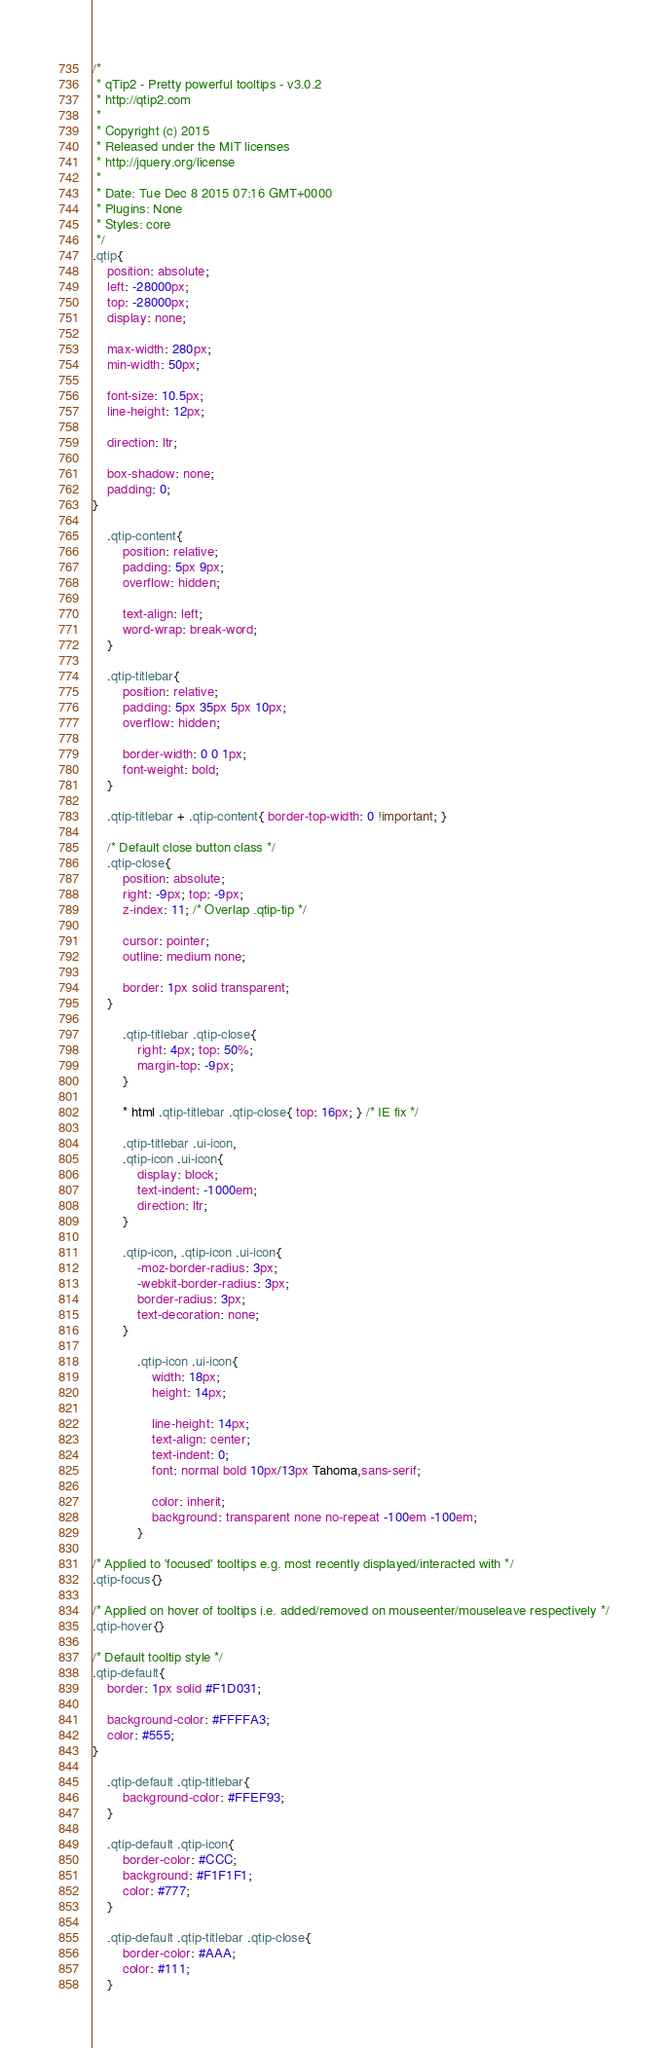Convert code to text. <code><loc_0><loc_0><loc_500><loc_500><_CSS_>/*
 * qTip2 - Pretty powerful tooltips - v3.0.2
 * http://qtip2.com
 *
 * Copyright (c) 2015 
 * Released under the MIT licenses
 * http://jquery.org/license
 *
 * Date: Tue Dec 8 2015 07:16 GMT+0000
 * Plugins: None
 * Styles: core
 */
.qtip{
	position: absolute;
	left: -28000px;
	top: -28000px;
	display: none;

	max-width: 280px;
	min-width: 50px;

	font-size: 10.5px;
	line-height: 12px;

	direction: ltr;

	box-shadow: none;
	padding: 0;
}

	.qtip-content{
		position: relative;
		padding: 5px 9px;
		overflow: hidden;

		text-align: left;
		word-wrap: break-word;
	}

	.qtip-titlebar{
		position: relative;
		padding: 5px 35px 5px 10px;
		overflow: hidden;

		border-width: 0 0 1px;
		font-weight: bold;
	}

	.qtip-titlebar + .qtip-content{ border-top-width: 0 !important; }

	/* Default close button class */
	.qtip-close{
		position: absolute;
		right: -9px; top: -9px;
		z-index: 11; /* Overlap .qtip-tip */

		cursor: pointer;
		outline: medium none;

		border: 1px solid transparent;
	}

		.qtip-titlebar .qtip-close{
			right: 4px; top: 50%;
			margin-top: -9px;
		}

		* html .qtip-titlebar .qtip-close{ top: 16px; } /* IE fix */

		.qtip-titlebar .ui-icon,
		.qtip-icon .ui-icon{
			display: block;
			text-indent: -1000em;
			direction: ltr;
		}

		.qtip-icon, .qtip-icon .ui-icon{
			-moz-border-radius: 3px;
			-webkit-border-radius: 3px;
			border-radius: 3px;
			text-decoration: none;
		}

			.qtip-icon .ui-icon{
				width: 18px;
				height: 14px;

				line-height: 14px;
				text-align: center;
				text-indent: 0;
				font: normal bold 10px/13px Tahoma,sans-serif;

				color: inherit;
				background: transparent none no-repeat -100em -100em;
			}

/* Applied to 'focused' tooltips e.g. most recently displayed/interacted with */
.qtip-focus{}

/* Applied on hover of tooltips i.e. added/removed on mouseenter/mouseleave respectively */
.qtip-hover{}

/* Default tooltip style */
.qtip-default{
	border: 1px solid #F1D031;

	background-color: #FFFFA3;
	color: #555;
}

	.qtip-default .qtip-titlebar{
		background-color: #FFEF93;
	}

	.qtip-default .qtip-icon{
		border-color: #CCC;
		background: #F1F1F1;
		color: #777;
	}

	.qtip-default .qtip-titlebar .qtip-close{
		border-color: #AAA;
		color: #111;
	}
</code> 